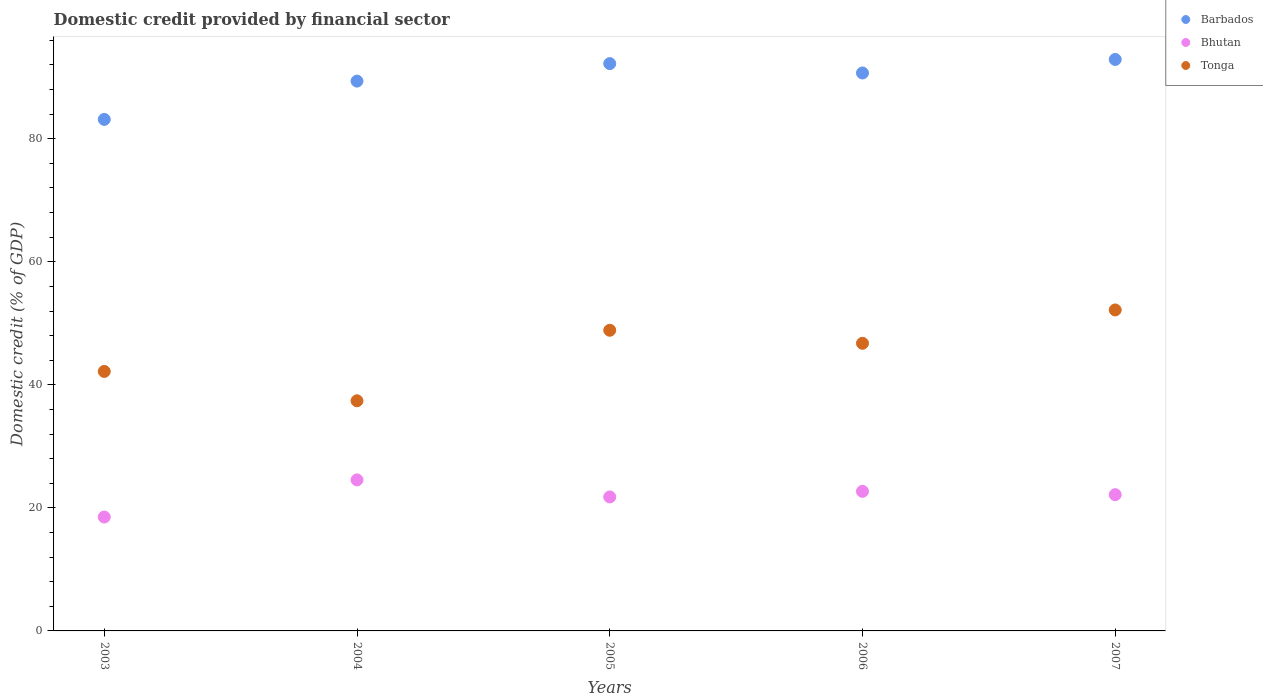What is the domestic credit in Barbados in 2006?
Make the answer very short. 90.69. Across all years, what is the maximum domestic credit in Tonga?
Keep it short and to the point. 52.17. Across all years, what is the minimum domestic credit in Tonga?
Offer a terse response. 37.41. In which year was the domestic credit in Barbados minimum?
Provide a succinct answer. 2003. What is the total domestic credit in Tonga in the graph?
Offer a terse response. 227.38. What is the difference between the domestic credit in Bhutan in 2005 and that in 2007?
Make the answer very short. -0.37. What is the difference between the domestic credit in Bhutan in 2005 and the domestic credit in Tonga in 2007?
Your answer should be compact. -30.39. What is the average domestic credit in Barbados per year?
Your answer should be compact. 89.66. In the year 2006, what is the difference between the domestic credit in Barbados and domestic credit in Tonga?
Give a very brief answer. 43.94. In how many years, is the domestic credit in Bhutan greater than 40 %?
Your answer should be very brief. 0. What is the ratio of the domestic credit in Tonga in 2004 to that in 2007?
Provide a short and direct response. 0.72. What is the difference between the highest and the second highest domestic credit in Barbados?
Ensure brevity in your answer.  0.68. What is the difference between the highest and the lowest domestic credit in Bhutan?
Keep it short and to the point. 6.04. Is the sum of the domestic credit in Tonga in 2005 and 2007 greater than the maximum domestic credit in Bhutan across all years?
Your answer should be compact. Yes. How many years are there in the graph?
Your answer should be very brief. 5. What is the difference between two consecutive major ticks on the Y-axis?
Your answer should be very brief. 20. Does the graph contain any zero values?
Offer a very short reply. No. Does the graph contain grids?
Your response must be concise. No. Where does the legend appear in the graph?
Give a very brief answer. Top right. How many legend labels are there?
Your answer should be very brief. 3. How are the legend labels stacked?
Ensure brevity in your answer.  Vertical. What is the title of the graph?
Give a very brief answer. Domestic credit provided by financial sector. Does "St. Kitts and Nevis" appear as one of the legend labels in the graph?
Provide a short and direct response. No. What is the label or title of the X-axis?
Offer a very short reply. Years. What is the label or title of the Y-axis?
Offer a terse response. Domestic credit (% of GDP). What is the Domestic credit (% of GDP) of Barbados in 2003?
Your answer should be compact. 83.14. What is the Domestic credit (% of GDP) in Bhutan in 2003?
Offer a terse response. 18.51. What is the Domestic credit (% of GDP) of Tonga in 2003?
Your answer should be compact. 42.18. What is the Domestic credit (% of GDP) in Barbados in 2004?
Give a very brief answer. 89.37. What is the Domestic credit (% of GDP) in Bhutan in 2004?
Make the answer very short. 24.55. What is the Domestic credit (% of GDP) in Tonga in 2004?
Make the answer very short. 37.41. What is the Domestic credit (% of GDP) in Barbados in 2005?
Keep it short and to the point. 92.21. What is the Domestic credit (% of GDP) of Bhutan in 2005?
Make the answer very short. 21.78. What is the Domestic credit (% of GDP) of Tonga in 2005?
Make the answer very short. 48.87. What is the Domestic credit (% of GDP) of Barbados in 2006?
Give a very brief answer. 90.69. What is the Domestic credit (% of GDP) of Bhutan in 2006?
Offer a very short reply. 22.69. What is the Domestic credit (% of GDP) of Tonga in 2006?
Keep it short and to the point. 46.75. What is the Domestic credit (% of GDP) in Barbados in 2007?
Your answer should be compact. 92.89. What is the Domestic credit (% of GDP) of Bhutan in 2007?
Offer a terse response. 22.15. What is the Domestic credit (% of GDP) of Tonga in 2007?
Offer a very short reply. 52.17. Across all years, what is the maximum Domestic credit (% of GDP) in Barbados?
Keep it short and to the point. 92.89. Across all years, what is the maximum Domestic credit (% of GDP) in Bhutan?
Keep it short and to the point. 24.55. Across all years, what is the maximum Domestic credit (% of GDP) in Tonga?
Your answer should be very brief. 52.17. Across all years, what is the minimum Domestic credit (% of GDP) in Barbados?
Provide a succinct answer. 83.14. Across all years, what is the minimum Domestic credit (% of GDP) of Bhutan?
Offer a very short reply. 18.51. Across all years, what is the minimum Domestic credit (% of GDP) in Tonga?
Your answer should be compact. 37.41. What is the total Domestic credit (% of GDP) in Barbados in the graph?
Offer a very short reply. 448.3. What is the total Domestic credit (% of GDP) of Bhutan in the graph?
Ensure brevity in your answer.  109.67. What is the total Domestic credit (% of GDP) in Tonga in the graph?
Make the answer very short. 227.38. What is the difference between the Domestic credit (% of GDP) in Barbados in 2003 and that in 2004?
Offer a very short reply. -6.23. What is the difference between the Domestic credit (% of GDP) of Bhutan in 2003 and that in 2004?
Make the answer very short. -6.04. What is the difference between the Domestic credit (% of GDP) in Tonga in 2003 and that in 2004?
Make the answer very short. 4.77. What is the difference between the Domestic credit (% of GDP) in Barbados in 2003 and that in 2005?
Provide a short and direct response. -9.07. What is the difference between the Domestic credit (% of GDP) in Bhutan in 2003 and that in 2005?
Your response must be concise. -3.27. What is the difference between the Domestic credit (% of GDP) in Tonga in 2003 and that in 2005?
Your answer should be compact. -6.69. What is the difference between the Domestic credit (% of GDP) in Barbados in 2003 and that in 2006?
Offer a very short reply. -7.55. What is the difference between the Domestic credit (% of GDP) in Bhutan in 2003 and that in 2006?
Provide a succinct answer. -4.18. What is the difference between the Domestic credit (% of GDP) of Tonga in 2003 and that in 2006?
Your answer should be very brief. -4.57. What is the difference between the Domestic credit (% of GDP) in Barbados in 2003 and that in 2007?
Give a very brief answer. -9.75. What is the difference between the Domestic credit (% of GDP) of Bhutan in 2003 and that in 2007?
Your answer should be compact. -3.64. What is the difference between the Domestic credit (% of GDP) of Tonga in 2003 and that in 2007?
Your answer should be very brief. -9.99. What is the difference between the Domestic credit (% of GDP) in Barbados in 2004 and that in 2005?
Ensure brevity in your answer.  -2.84. What is the difference between the Domestic credit (% of GDP) of Bhutan in 2004 and that in 2005?
Your response must be concise. 2.77. What is the difference between the Domestic credit (% of GDP) of Tonga in 2004 and that in 2005?
Keep it short and to the point. -11.46. What is the difference between the Domestic credit (% of GDP) in Barbados in 2004 and that in 2006?
Ensure brevity in your answer.  -1.32. What is the difference between the Domestic credit (% of GDP) in Bhutan in 2004 and that in 2006?
Offer a terse response. 1.86. What is the difference between the Domestic credit (% of GDP) of Tonga in 2004 and that in 2006?
Keep it short and to the point. -9.35. What is the difference between the Domestic credit (% of GDP) of Barbados in 2004 and that in 2007?
Ensure brevity in your answer.  -3.52. What is the difference between the Domestic credit (% of GDP) of Bhutan in 2004 and that in 2007?
Keep it short and to the point. 2.4. What is the difference between the Domestic credit (% of GDP) of Tonga in 2004 and that in 2007?
Ensure brevity in your answer.  -14.77. What is the difference between the Domestic credit (% of GDP) of Barbados in 2005 and that in 2006?
Offer a terse response. 1.52. What is the difference between the Domestic credit (% of GDP) of Bhutan in 2005 and that in 2006?
Provide a short and direct response. -0.91. What is the difference between the Domestic credit (% of GDP) in Tonga in 2005 and that in 2006?
Offer a very short reply. 2.12. What is the difference between the Domestic credit (% of GDP) of Barbados in 2005 and that in 2007?
Keep it short and to the point. -0.68. What is the difference between the Domestic credit (% of GDP) of Bhutan in 2005 and that in 2007?
Make the answer very short. -0.37. What is the difference between the Domestic credit (% of GDP) of Tonga in 2005 and that in 2007?
Make the answer very short. -3.3. What is the difference between the Domestic credit (% of GDP) of Barbados in 2006 and that in 2007?
Your response must be concise. -2.2. What is the difference between the Domestic credit (% of GDP) of Bhutan in 2006 and that in 2007?
Your answer should be very brief. 0.54. What is the difference between the Domestic credit (% of GDP) of Tonga in 2006 and that in 2007?
Your answer should be compact. -5.42. What is the difference between the Domestic credit (% of GDP) of Barbados in 2003 and the Domestic credit (% of GDP) of Bhutan in 2004?
Offer a very short reply. 58.59. What is the difference between the Domestic credit (% of GDP) in Barbados in 2003 and the Domestic credit (% of GDP) in Tonga in 2004?
Provide a succinct answer. 45.74. What is the difference between the Domestic credit (% of GDP) of Bhutan in 2003 and the Domestic credit (% of GDP) of Tonga in 2004?
Ensure brevity in your answer.  -18.89. What is the difference between the Domestic credit (% of GDP) of Barbados in 2003 and the Domestic credit (% of GDP) of Bhutan in 2005?
Offer a terse response. 61.36. What is the difference between the Domestic credit (% of GDP) in Barbados in 2003 and the Domestic credit (% of GDP) in Tonga in 2005?
Your answer should be compact. 34.27. What is the difference between the Domestic credit (% of GDP) of Bhutan in 2003 and the Domestic credit (% of GDP) of Tonga in 2005?
Ensure brevity in your answer.  -30.36. What is the difference between the Domestic credit (% of GDP) in Barbados in 2003 and the Domestic credit (% of GDP) in Bhutan in 2006?
Offer a terse response. 60.45. What is the difference between the Domestic credit (% of GDP) in Barbados in 2003 and the Domestic credit (% of GDP) in Tonga in 2006?
Offer a very short reply. 36.39. What is the difference between the Domestic credit (% of GDP) of Bhutan in 2003 and the Domestic credit (% of GDP) of Tonga in 2006?
Ensure brevity in your answer.  -28.24. What is the difference between the Domestic credit (% of GDP) of Barbados in 2003 and the Domestic credit (% of GDP) of Bhutan in 2007?
Your response must be concise. 61. What is the difference between the Domestic credit (% of GDP) of Barbados in 2003 and the Domestic credit (% of GDP) of Tonga in 2007?
Provide a succinct answer. 30.97. What is the difference between the Domestic credit (% of GDP) of Bhutan in 2003 and the Domestic credit (% of GDP) of Tonga in 2007?
Offer a very short reply. -33.66. What is the difference between the Domestic credit (% of GDP) of Barbados in 2004 and the Domestic credit (% of GDP) of Bhutan in 2005?
Give a very brief answer. 67.59. What is the difference between the Domestic credit (% of GDP) in Barbados in 2004 and the Domestic credit (% of GDP) in Tonga in 2005?
Keep it short and to the point. 40.5. What is the difference between the Domestic credit (% of GDP) in Bhutan in 2004 and the Domestic credit (% of GDP) in Tonga in 2005?
Your answer should be compact. -24.32. What is the difference between the Domestic credit (% of GDP) of Barbados in 2004 and the Domestic credit (% of GDP) of Bhutan in 2006?
Ensure brevity in your answer.  66.68. What is the difference between the Domestic credit (% of GDP) of Barbados in 2004 and the Domestic credit (% of GDP) of Tonga in 2006?
Your response must be concise. 42.62. What is the difference between the Domestic credit (% of GDP) in Bhutan in 2004 and the Domestic credit (% of GDP) in Tonga in 2006?
Your answer should be very brief. -22.2. What is the difference between the Domestic credit (% of GDP) in Barbados in 2004 and the Domestic credit (% of GDP) in Bhutan in 2007?
Offer a terse response. 67.22. What is the difference between the Domestic credit (% of GDP) of Barbados in 2004 and the Domestic credit (% of GDP) of Tonga in 2007?
Your answer should be compact. 37.2. What is the difference between the Domestic credit (% of GDP) in Bhutan in 2004 and the Domestic credit (% of GDP) in Tonga in 2007?
Your response must be concise. -27.62. What is the difference between the Domestic credit (% of GDP) in Barbados in 2005 and the Domestic credit (% of GDP) in Bhutan in 2006?
Offer a very short reply. 69.52. What is the difference between the Domestic credit (% of GDP) of Barbados in 2005 and the Domestic credit (% of GDP) of Tonga in 2006?
Your answer should be compact. 45.46. What is the difference between the Domestic credit (% of GDP) in Bhutan in 2005 and the Domestic credit (% of GDP) in Tonga in 2006?
Offer a very short reply. -24.97. What is the difference between the Domestic credit (% of GDP) of Barbados in 2005 and the Domestic credit (% of GDP) of Bhutan in 2007?
Your answer should be compact. 70.07. What is the difference between the Domestic credit (% of GDP) of Barbados in 2005 and the Domestic credit (% of GDP) of Tonga in 2007?
Keep it short and to the point. 40.04. What is the difference between the Domestic credit (% of GDP) of Bhutan in 2005 and the Domestic credit (% of GDP) of Tonga in 2007?
Your answer should be very brief. -30.39. What is the difference between the Domestic credit (% of GDP) in Barbados in 2006 and the Domestic credit (% of GDP) in Bhutan in 2007?
Provide a short and direct response. 68.54. What is the difference between the Domestic credit (% of GDP) in Barbados in 2006 and the Domestic credit (% of GDP) in Tonga in 2007?
Make the answer very short. 38.52. What is the difference between the Domestic credit (% of GDP) of Bhutan in 2006 and the Domestic credit (% of GDP) of Tonga in 2007?
Ensure brevity in your answer.  -29.48. What is the average Domestic credit (% of GDP) of Barbados per year?
Offer a very short reply. 89.66. What is the average Domestic credit (% of GDP) of Bhutan per year?
Your answer should be compact. 21.93. What is the average Domestic credit (% of GDP) of Tonga per year?
Offer a terse response. 45.48. In the year 2003, what is the difference between the Domestic credit (% of GDP) of Barbados and Domestic credit (% of GDP) of Bhutan?
Provide a short and direct response. 64.63. In the year 2003, what is the difference between the Domestic credit (% of GDP) of Barbados and Domestic credit (% of GDP) of Tonga?
Make the answer very short. 40.96. In the year 2003, what is the difference between the Domestic credit (% of GDP) of Bhutan and Domestic credit (% of GDP) of Tonga?
Offer a terse response. -23.67. In the year 2004, what is the difference between the Domestic credit (% of GDP) of Barbados and Domestic credit (% of GDP) of Bhutan?
Provide a short and direct response. 64.82. In the year 2004, what is the difference between the Domestic credit (% of GDP) in Barbados and Domestic credit (% of GDP) in Tonga?
Provide a short and direct response. 51.96. In the year 2004, what is the difference between the Domestic credit (% of GDP) in Bhutan and Domestic credit (% of GDP) in Tonga?
Give a very brief answer. -12.86. In the year 2005, what is the difference between the Domestic credit (% of GDP) of Barbados and Domestic credit (% of GDP) of Bhutan?
Provide a short and direct response. 70.43. In the year 2005, what is the difference between the Domestic credit (% of GDP) in Barbados and Domestic credit (% of GDP) in Tonga?
Keep it short and to the point. 43.34. In the year 2005, what is the difference between the Domestic credit (% of GDP) of Bhutan and Domestic credit (% of GDP) of Tonga?
Make the answer very short. -27.09. In the year 2006, what is the difference between the Domestic credit (% of GDP) in Barbados and Domestic credit (% of GDP) in Bhutan?
Give a very brief answer. 68. In the year 2006, what is the difference between the Domestic credit (% of GDP) in Barbados and Domestic credit (% of GDP) in Tonga?
Give a very brief answer. 43.94. In the year 2006, what is the difference between the Domestic credit (% of GDP) of Bhutan and Domestic credit (% of GDP) of Tonga?
Make the answer very short. -24.06. In the year 2007, what is the difference between the Domestic credit (% of GDP) in Barbados and Domestic credit (% of GDP) in Bhutan?
Your answer should be very brief. 70.74. In the year 2007, what is the difference between the Domestic credit (% of GDP) of Barbados and Domestic credit (% of GDP) of Tonga?
Offer a terse response. 40.72. In the year 2007, what is the difference between the Domestic credit (% of GDP) of Bhutan and Domestic credit (% of GDP) of Tonga?
Ensure brevity in your answer.  -30.03. What is the ratio of the Domestic credit (% of GDP) in Barbados in 2003 to that in 2004?
Your answer should be very brief. 0.93. What is the ratio of the Domestic credit (% of GDP) in Bhutan in 2003 to that in 2004?
Provide a succinct answer. 0.75. What is the ratio of the Domestic credit (% of GDP) of Tonga in 2003 to that in 2004?
Ensure brevity in your answer.  1.13. What is the ratio of the Domestic credit (% of GDP) of Barbados in 2003 to that in 2005?
Provide a short and direct response. 0.9. What is the ratio of the Domestic credit (% of GDP) in Bhutan in 2003 to that in 2005?
Offer a very short reply. 0.85. What is the ratio of the Domestic credit (% of GDP) in Tonga in 2003 to that in 2005?
Give a very brief answer. 0.86. What is the ratio of the Domestic credit (% of GDP) of Barbados in 2003 to that in 2006?
Your answer should be very brief. 0.92. What is the ratio of the Domestic credit (% of GDP) in Bhutan in 2003 to that in 2006?
Offer a terse response. 0.82. What is the ratio of the Domestic credit (% of GDP) of Tonga in 2003 to that in 2006?
Your answer should be compact. 0.9. What is the ratio of the Domestic credit (% of GDP) in Barbados in 2003 to that in 2007?
Keep it short and to the point. 0.9. What is the ratio of the Domestic credit (% of GDP) of Bhutan in 2003 to that in 2007?
Your answer should be very brief. 0.84. What is the ratio of the Domestic credit (% of GDP) of Tonga in 2003 to that in 2007?
Provide a short and direct response. 0.81. What is the ratio of the Domestic credit (% of GDP) in Barbados in 2004 to that in 2005?
Your answer should be compact. 0.97. What is the ratio of the Domestic credit (% of GDP) of Bhutan in 2004 to that in 2005?
Your answer should be very brief. 1.13. What is the ratio of the Domestic credit (% of GDP) of Tonga in 2004 to that in 2005?
Offer a very short reply. 0.77. What is the ratio of the Domestic credit (% of GDP) of Barbados in 2004 to that in 2006?
Give a very brief answer. 0.99. What is the ratio of the Domestic credit (% of GDP) of Bhutan in 2004 to that in 2006?
Ensure brevity in your answer.  1.08. What is the ratio of the Domestic credit (% of GDP) of Tonga in 2004 to that in 2006?
Provide a short and direct response. 0.8. What is the ratio of the Domestic credit (% of GDP) of Barbados in 2004 to that in 2007?
Offer a terse response. 0.96. What is the ratio of the Domestic credit (% of GDP) in Bhutan in 2004 to that in 2007?
Provide a short and direct response. 1.11. What is the ratio of the Domestic credit (% of GDP) in Tonga in 2004 to that in 2007?
Provide a short and direct response. 0.72. What is the ratio of the Domestic credit (% of GDP) of Barbados in 2005 to that in 2006?
Make the answer very short. 1.02. What is the ratio of the Domestic credit (% of GDP) in Bhutan in 2005 to that in 2006?
Offer a very short reply. 0.96. What is the ratio of the Domestic credit (% of GDP) in Tonga in 2005 to that in 2006?
Offer a terse response. 1.05. What is the ratio of the Domestic credit (% of GDP) in Barbados in 2005 to that in 2007?
Ensure brevity in your answer.  0.99. What is the ratio of the Domestic credit (% of GDP) of Bhutan in 2005 to that in 2007?
Provide a short and direct response. 0.98. What is the ratio of the Domestic credit (% of GDP) in Tonga in 2005 to that in 2007?
Offer a very short reply. 0.94. What is the ratio of the Domestic credit (% of GDP) in Barbados in 2006 to that in 2007?
Offer a very short reply. 0.98. What is the ratio of the Domestic credit (% of GDP) of Bhutan in 2006 to that in 2007?
Offer a very short reply. 1.02. What is the ratio of the Domestic credit (% of GDP) in Tonga in 2006 to that in 2007?
Keep it short and to the point. 0.9. What is the difference between the highest and the second highest Domestic credit (% of GDP) of Barbados?
Provide a short and direct response. 0.68. What is the difference between the highest and the second highest Domestic credit (% of GDP) in Bhutan?
Offer a very short reply. 1.86. What is the difference between the highest and the second highest Domestic credit (% of GDP) in Tonga?
Keep it short and to the point. 3.3. What is the difference between the highest and the lowest Domestic credit (% of GDP) of Barbados?
Provide a succinct answer. 9.75. What is the difference between the highest and the lowest Domestic credit (% of GDP) of Bhutan?
Provide a short and direct response. 6.04. What is the difference between the highest and the lowest Domestic credit (% of GDP) in Tonga?
Make the answer very short. 14.77. 